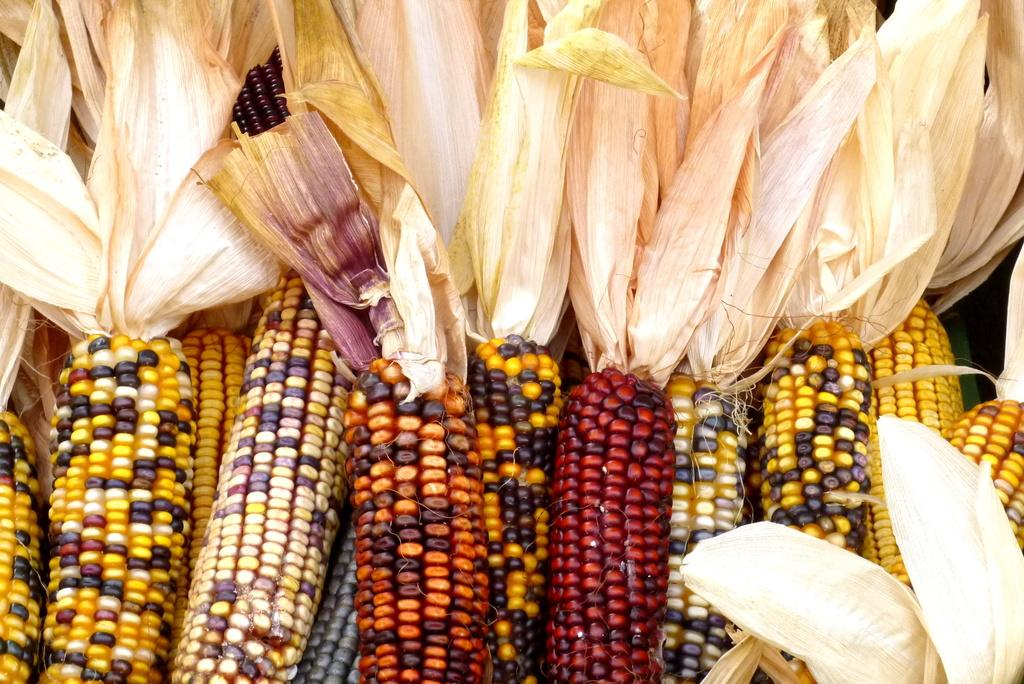What is the main subject of the image? There is a bunch of maize in the image. Can you describe the appearance of the maize? The maize appears to be in a bunch, with multiple stalks and ears of corn. What might be the purpose of the maize in the image? The purpose of the maize in the image is not explicitly stated, but it could be for decoration, food, or agricultural purposes. How many brothers are depicted in the image? There are no people, including brothers, present in the image; it features a bunch of maize. What type of basin is used to hold the maize in the image? There is no basin present in the image; the maize is not contained in any type of container. 